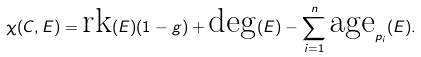<formula> <loc_0><loc_0><loc_500><loc_500>\chi ( C , E ) = \text {rk} ( E ) ( 1 - g ) + \text {deg} ( E ) - \sum _ { i = 1 } ^ { n } \text {age} _ { p _ { i } } ( E ) .</formula> 